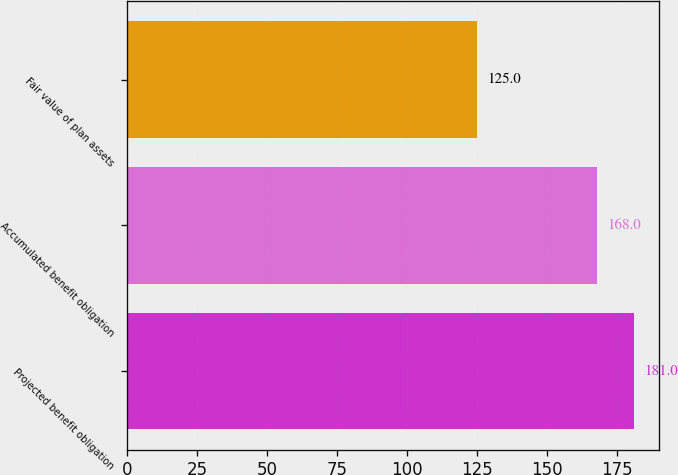Convert chart. <chart><loc_0><loc_0><loc_500><loc_500><bar_chart><fcel>Projected benefit obligation<fcel>Accumulated benefit obligation<fcel>Fair value of plan assets<nl><fcel>181<fcel>168<fcel>125<nl></chart> 